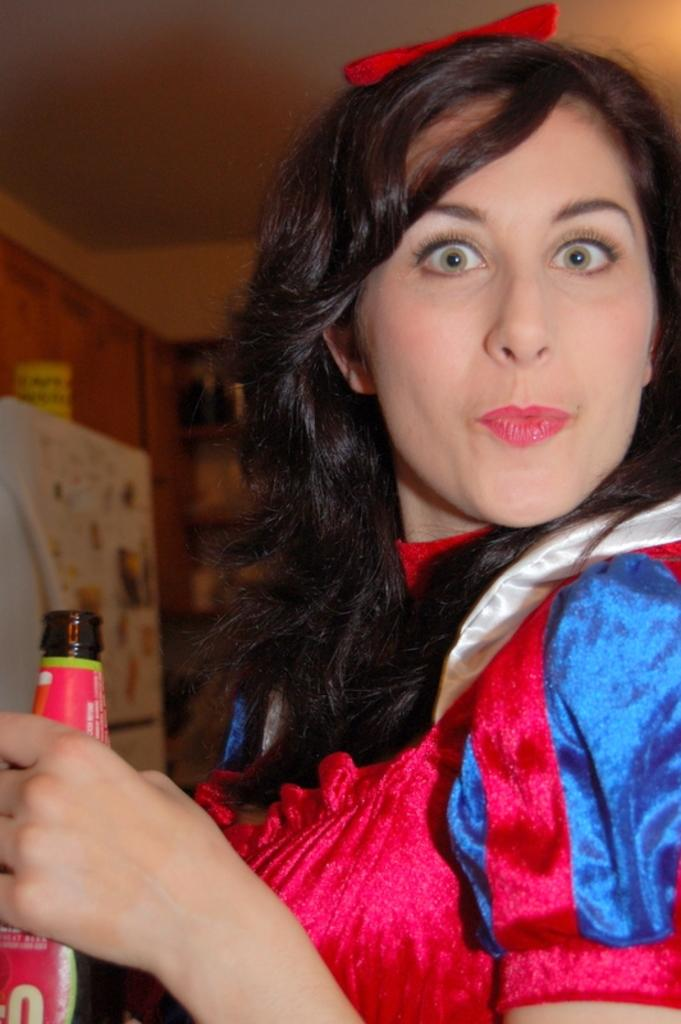Who is present in the image? There is a woman in the image. What is the woman wearing? The woman is wearing a red dress and a red ribbon. What is the woman holding in the image? The woman is holding a bottle. What can be seen on the bottle? The bottle is labeled in red. What is visible in the background of the image? There are cupboards, a fridge, and a wall in the background of the image. How many screws can be seen on the wall in the image? There are no screws visible in the image; the wall is part of the background and does not have any visible screws. 